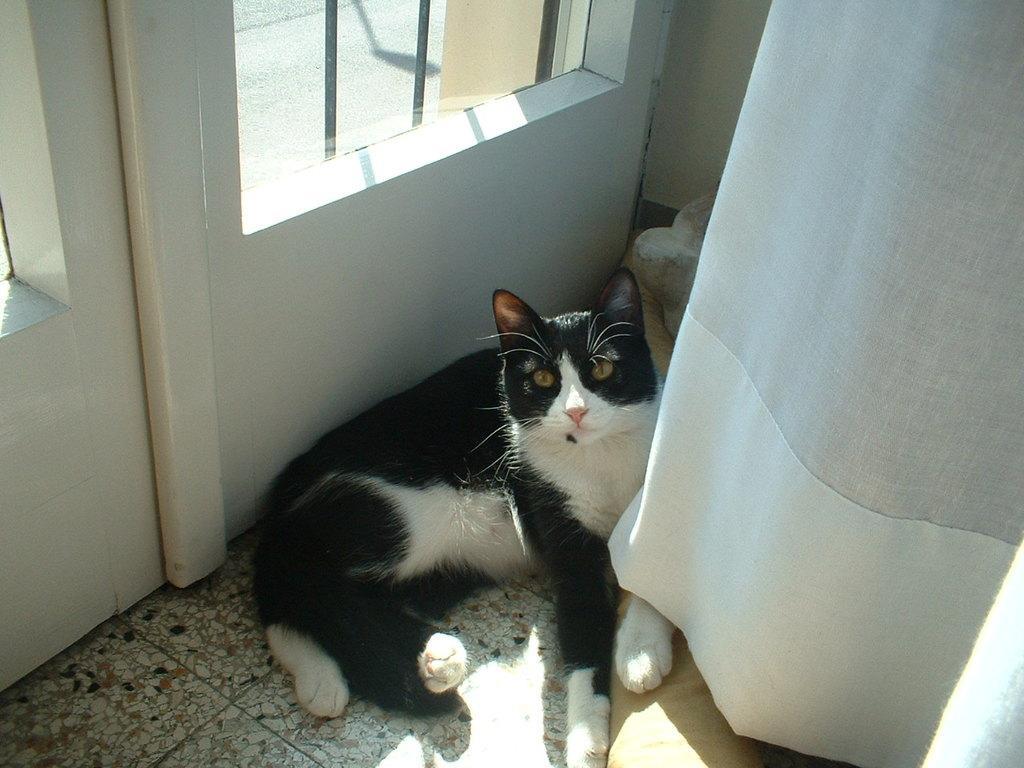Describe this image in one or two sentences. This image is taken indoors. At the bottom of the image there is a floor. In the background there is a wall with a window. On the right side of the image there is a curtain. In the middle of the image a cat is lying on the floor. 